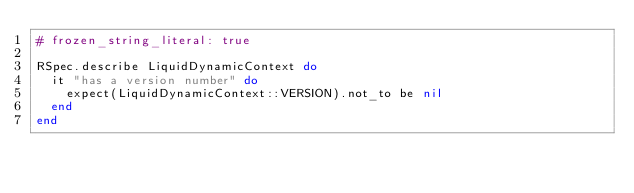Convert code to text. <code><loc_0><loc_0><loc_500><loc_500><_Ruby_># frozen_string_literal: true

RSpec.describe LiquidDynamicContext do
  it "has a version number" do
    expect(LiquidDynamicContext::VERSION).not_to be nil
  end
end
</code> 